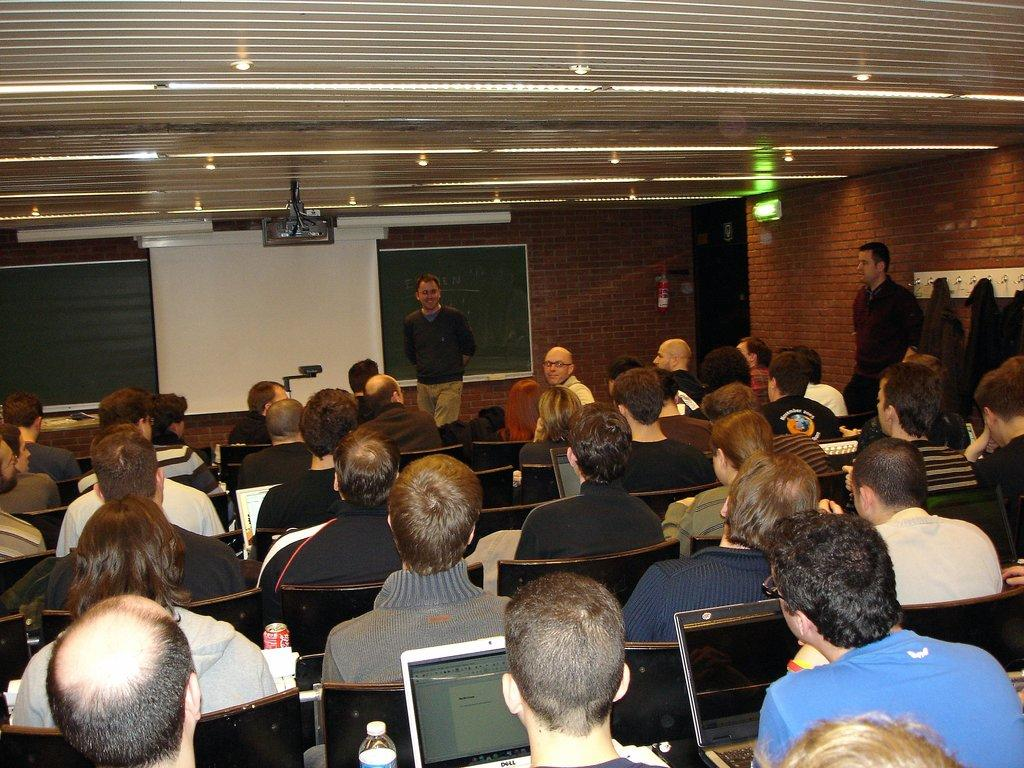What are the people in the image doing? The people in the image are sitting on chairs. How many men are standing in the image? There are two men standing in the image. What object can be seen hanging in the image? There is a hanger in the image. What is the purpose of the board in the image? The purpose of the board in the image is not clear from the facts provided. What color is the banner in the image? The banner in the image is white. What is the background of the image made of? The background of the image includes a wall. What can be seen at the top of the image? Lights and a projector are visible at the top of the image. Can you tell me how many degrees the ocean is in the image? There is no ocean present in the image, so it is not possible to determine its temperature. What type of error is being corrected by the people in the image? There is no indication of an error or correction being made in the image. 